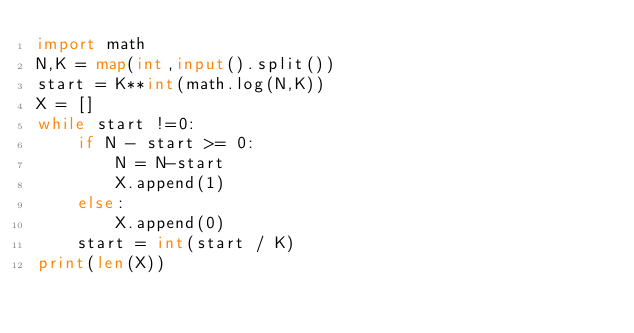Convert code to text. <code><loc_0><loc_0><loc_500><loc_500><_Python_>import math
N,K = map(int,input().split())
start = K**int(math.log(N,K))
X = []
while start !=0:
    if N - start >= 0:
        N = N-start
        X.append(1)
    else:
        X.append(0)
    start = int(start / K)
print(len(X))</code> 